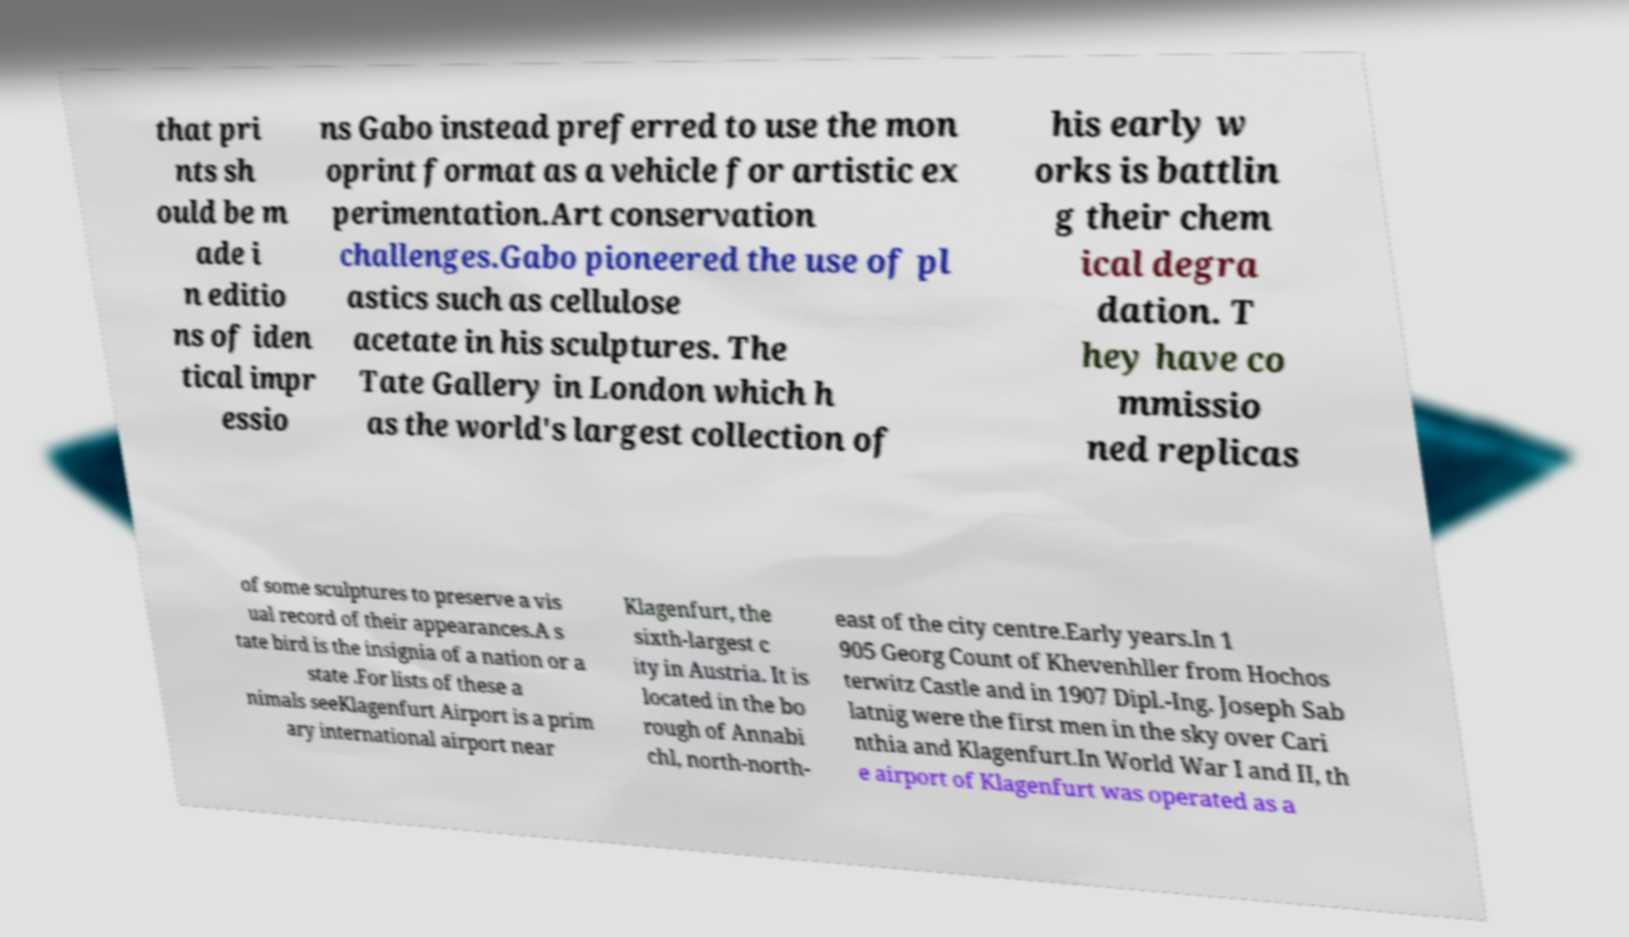Can you read and provide the text displayed in the image?This photo seems to have some interesting text. Can you extract and type it out for me? that pri nts sh ould be m ade i n editio ns of iden tical impr essio ns Gabo instead preferred to use the mon oprint format as a vehicle for artistic ex perimentation.Art conservation challenges.Gabo pioneered the use of pl astics such as cellulose acetate in his sculptures. The Tate Gallery in London which h as the world's largest collection of his early w orks is battlin g their chem ical degra dation. T hey have co mmissio ned replicas of some sculptures to preserve a vis ual record of their appearances.A s tate bird is the insignia of a nation or a state .For lists of these a nimals seeKlagenfurt Airport is a prim ary international airport near Klagenfurt, the sixth-largest c ity in Austria. It is located in the bo rough of Annabi chl, north-north- east of the city centre.Early years.In 1 905 Georg Count of Khevenhller from Hochos terwitz Castle and in 1907 Dipl.-Ing. Joseph Sab latnig were the first men in the sky over Cari nthia and Klagenfurt.In World War I and II, th e airport of Klagenfurt was operated as a 